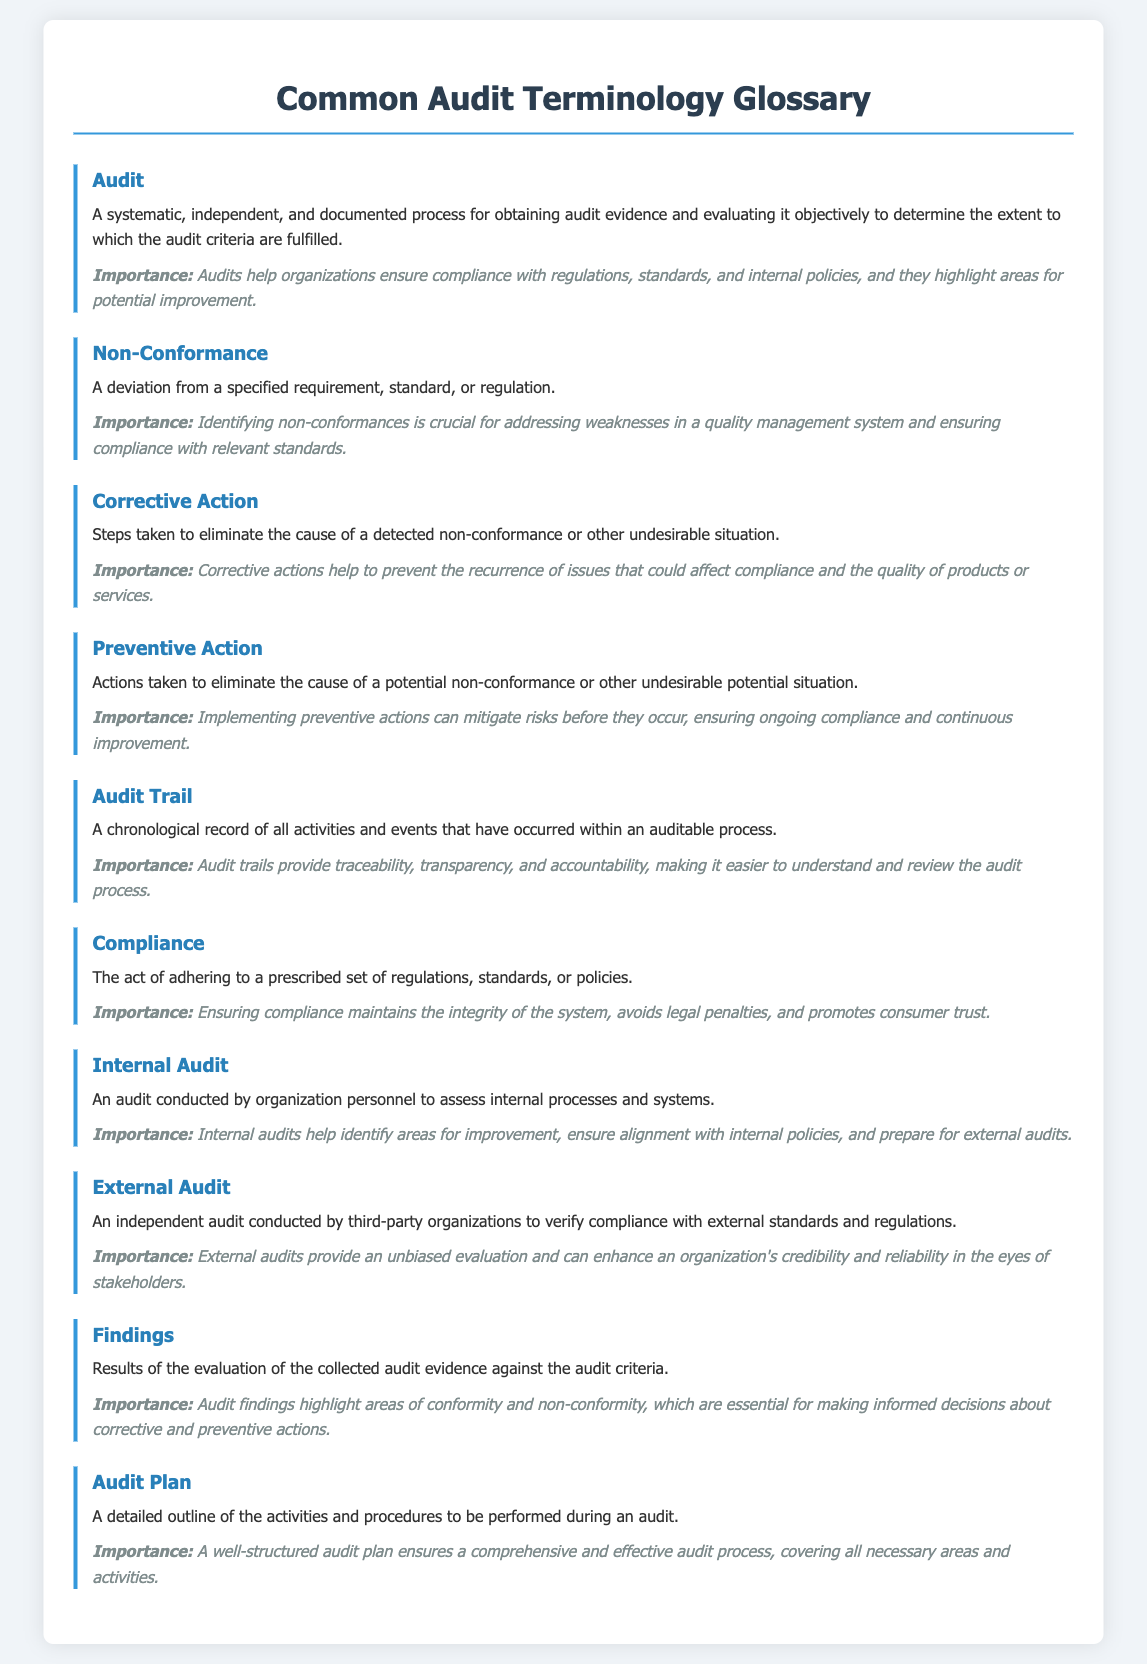What is the definition of Audit? The definition states that an audit is a systematic, independent, and documented process for obtaining audit evidence and evaluating it objectively.
Answer: A systematic, independent, and documented process What term describes a deviation from a specified requirement? The document states that a non-conformance is the term that describes a deviation from a specified requirement, standard, or regulation.
Answer: Non-Conformance What steps are taken to eliminate the cause of a non-conformance? The document defines corrective action as the steps taken to eliminate the cause of a detected non-conformance or other undesirable situation.
Answer: Corrective Action What is an Audit Trail? The document defines an audit trail as a chronological record of all activities and events that have occurred within an auditable process.
Answer: A chronological record of all activities and events What action is taken to eliminate potential non-conformance? Preventive action is defined in the document as actions taken to eliminate the cause of a potential non-conformance.
Answer: Preventive Action What is the importance of Compliance according to the document? The importance section states that ensuring compliance maintains the integrity of the system, avoids legal penalties, and promotes consumer trust.
Answer: Maintains integrity, avoids legal penalties, promotes consumer trust How many types of audits are mentioned in the glossary? The document mentions two types of audits: internal audit and external audit.
Answer: Two What are Findings in the context of an audit? The document describes findings as the results of the evaluation of the collected audit evidence against the audit criteria.
Answer: Evaluation results of audit evidence What does an Audit Plan outline? The audit plan is defined as a detailed outline of the activities and procedures to be performed during an audit.
Answer: Activities and procedures to be performed 